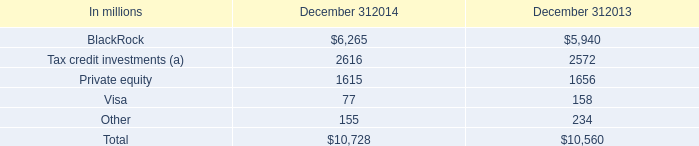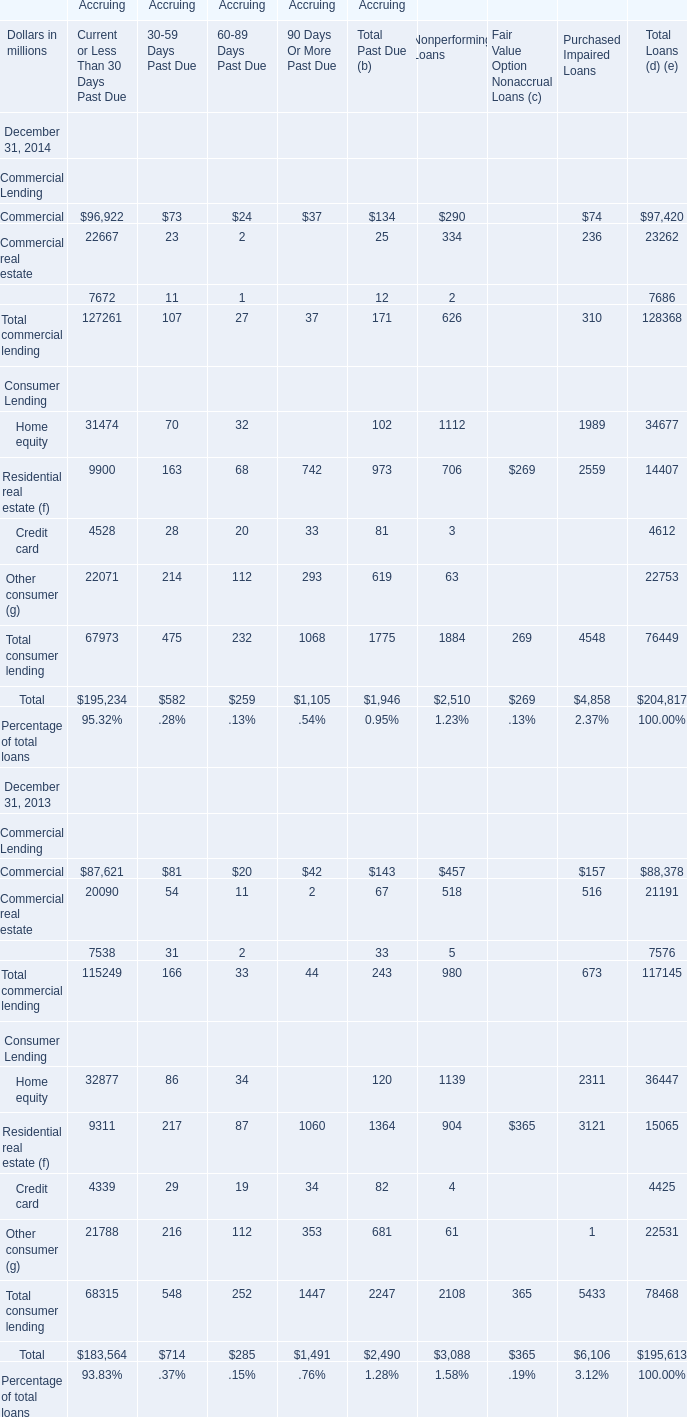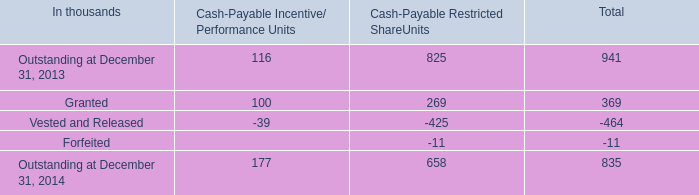In which year is the value of Total commercial lending for Accruing 90 Days Or More Past Due on December 31 higher? 
Answer: 2013. 